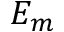Convert formula to latex. <formula><loc_0><loc_0><loc_500><loc_500>E _ { m }</formula> 